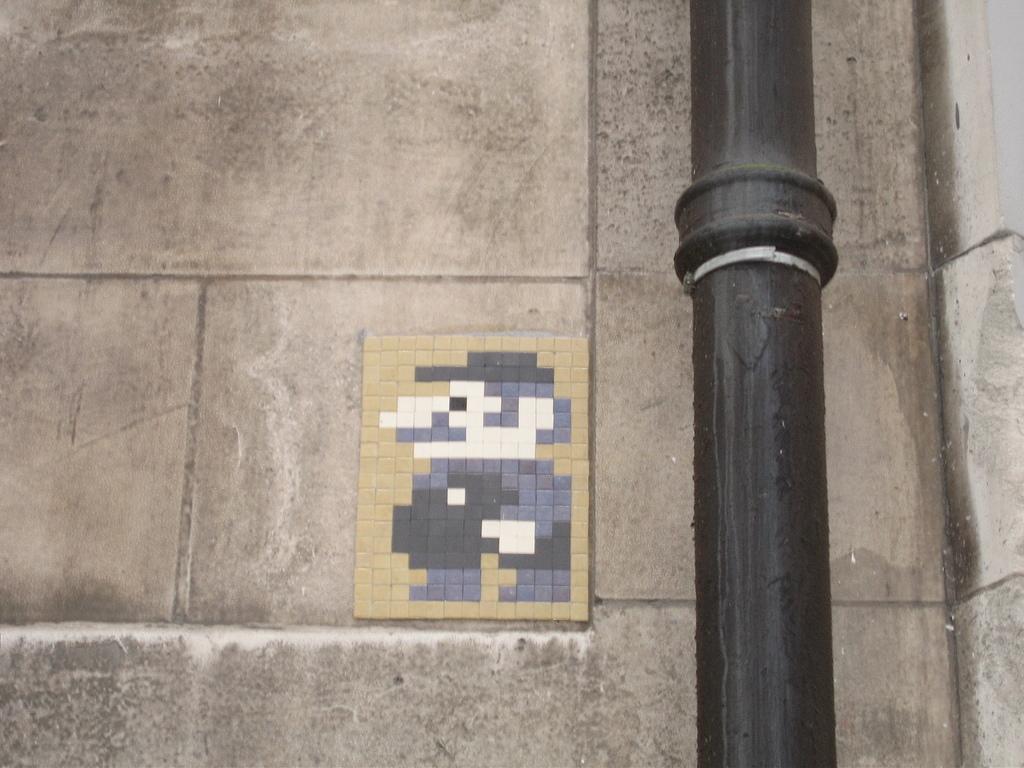Please provide a concise description of this image. In this image, on the right side, we can see a black color pole. In the middle of the image, we can see a puzzle board. In the background, we can see a wall. 